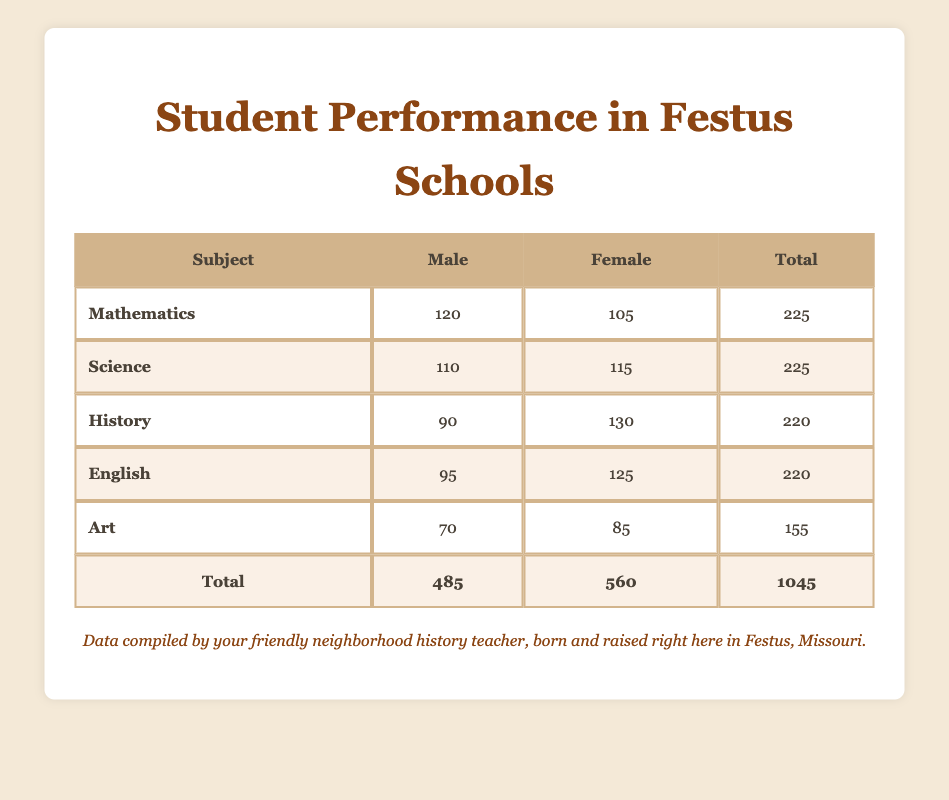What is the total number of male students across all subjects? The total number of male students can be found by adding the number of males in each subject: 120 (Mathematics) + 110 (Science) + 90 (History) + 95 (English) + 70 (Art) = 485
Answer: 485 What is the total number of female students in English? The table states that there are 125 female students in English, which is a direct retrieval from the data provided
Answer: 125 Which subject had the highest number of female students? By comparing the female student counts in all subjects, we see: 105 (Mathematics), 115 (Science), 130 (History), 125 (English), 85 (Art). The highest is 130 in History
Answer: History Is the number of male students in Science greater than those in Art? There are 110 male students in Science and 70 male students in Art. Since 110 is greater than 70, the statement is true
Answer: Yes What is the difference in the number of male and female students in Mathematics? In Mathematics, there are 120 male students and 105 female students. The difference is calculated as 120 - 105 = 15
Answer: 15 How many more female students are there than male students in History? For History, there are 90 male students and 130 female students. The difference is 130 - 90 = 40, indicating there are 40 more female students
Answer: 40 What is the average number of male students per subject? The total number of male students is 485, and there are 5 subjects. The average is 485 divided by 5, which equals 97
Answer: 97 Which gender performed better in Math? In Math, there are 120 male and 105 female students. Comparing these numbers, males outnumber females, so males performed better
Answer: Male What is the total number of students in History and Art combined? History has 220 students and Art has 155 students. Adding these gives: 220 + 155 = 375, which is the total number of students in both subjects
Answer: 375 What is the total number of students across all subjects? The total number of students across all subjects is calculated by summing the totals from each subject: 225 (Math) + 225 (Science) + 220 (History) + 220 (English) + 155 (Art) = 1045
Answer: 1045 